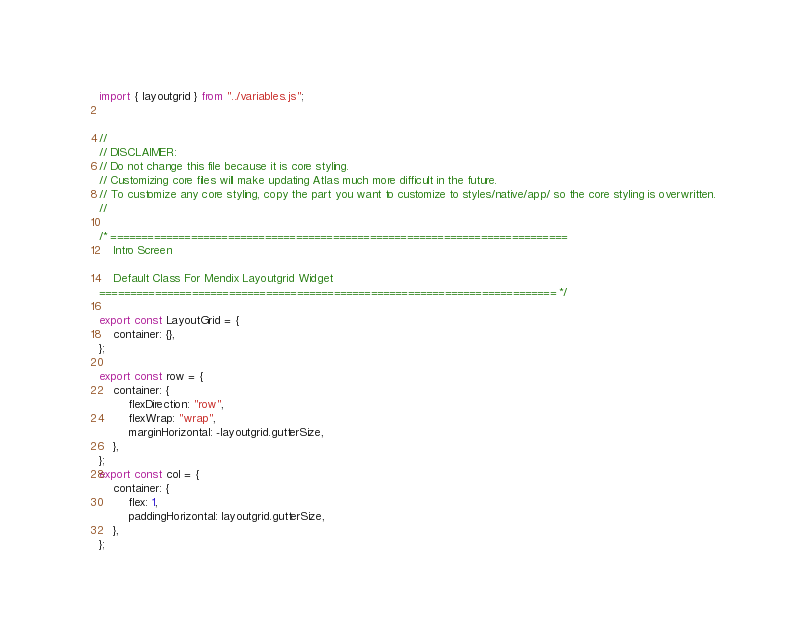Convert code to text. <code><loc_0><loc_0><loc_500><loc_500><_JavaScript_>import { layoutgrid } from "../variables.js";


//
// DISCLAIMER:
// Do not change this file because it is core styling.
// Customizing core files will make updating Atlas much more difficult in the future.
// To customize any core styling, copy the part you want to customize to styles/native/app/ so the core styling is overwritten.
//

/* ==========================================================================
    Intro Screen

    Default Class For Mendix Layoutgrid Widget
========================================================================== */

export const LayoutGrid = {
    container: {},
};

export const row = {
    container: {
        flexDirection: "row",
        flexWrap: "wrap",
        marginHorizontal: -layoutgrid.gutterSize,
    },
};
export const col = {
    container: {
        flex: 1,
        paddingHorizontal: layoutgrid.gutterSize,
    },
};</code> 